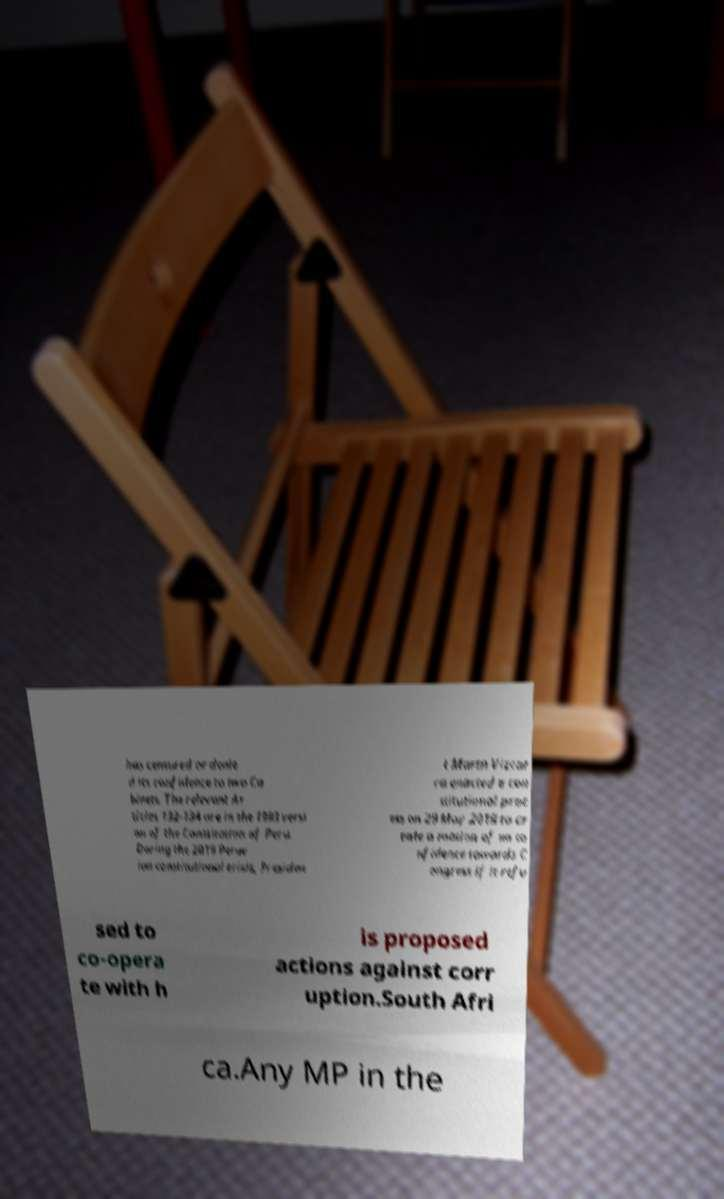For documentation purposes, I need the text within this image transcribed. Could you provide that? has censured or denie d its confidence to two Ca binets. The relevant Ar ticles 132-134 are in the 1993 versi on of the Constitution of Peru. During the 2019 Peruv ian constitutional crisis, Presiden t Martn Vizcar ra enacted a con stitutional proc ess on 29 May 2019 to cr eate a motion of no co nfidence towards C ongress if it refu sed to co-opera te with h is proposed actions against corr uption.South Afri ca.Any MP in the 